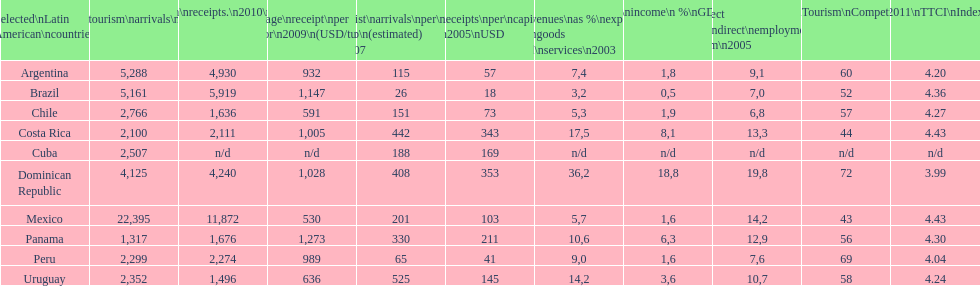Which latin american country had the largest number of tourism arrivals in 2010? Mexico. 